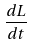Convert formula to latex. <formula><loc_0><loc_0><loc_500><loc_500>\frac { d L } { d t }</formula> 